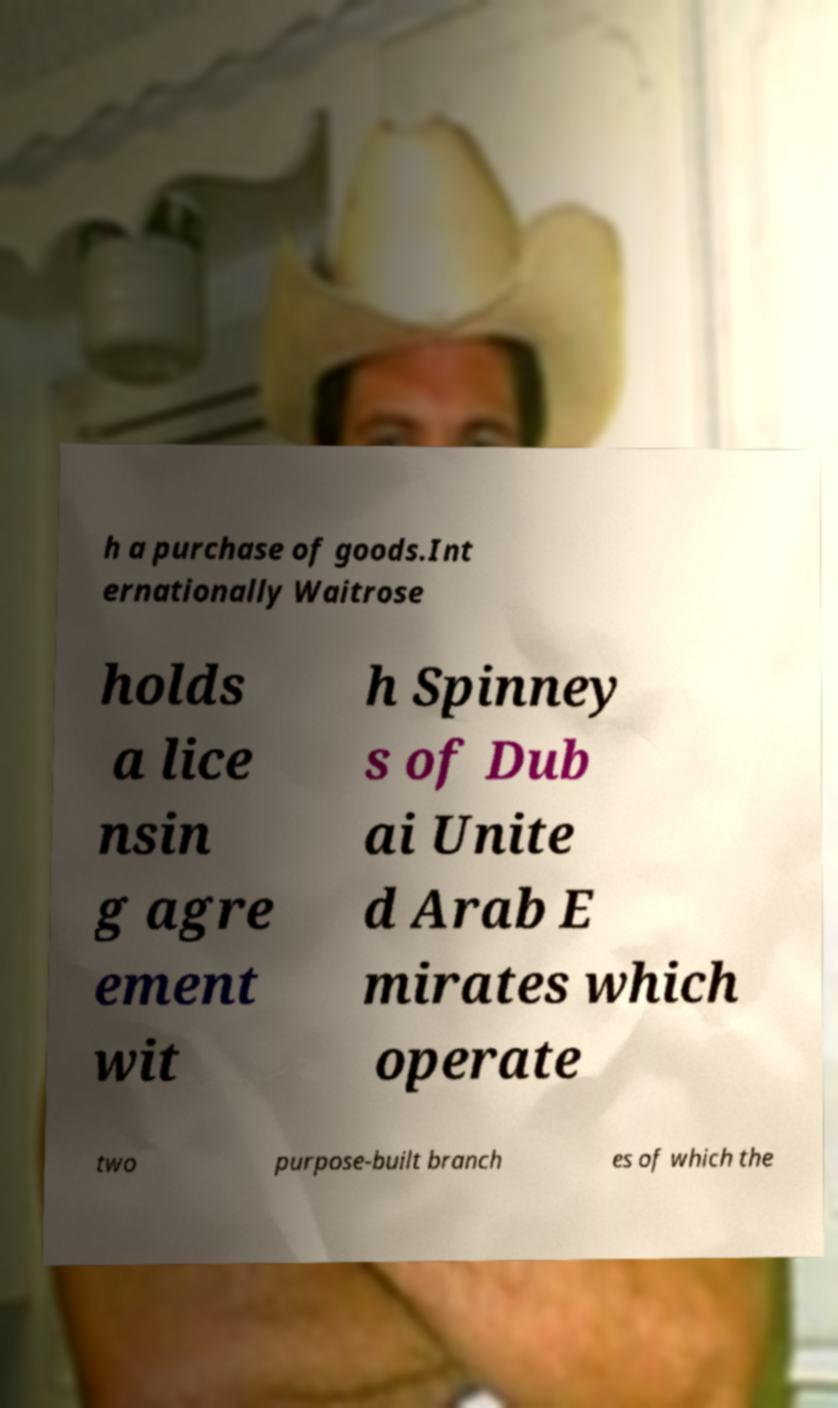Can you read and provide the text displayed in the image?This photo seems to have some interesting text. Can you extract and type it out for me? h a purchase of goods.Int ernationally Waitrose holds a lice nsin g agre ement wit h Spinney s of Dub ai Unite d Arab E mirates which operate two purpose-built branch es of which the 